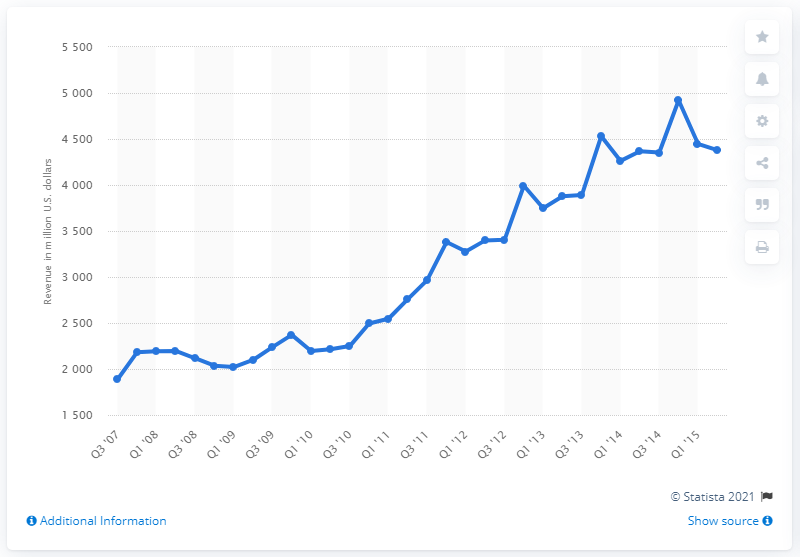Mention a couple of crucial points in this snapshot. In the second quarter of 2015, eBay's revenue was 4,379. 